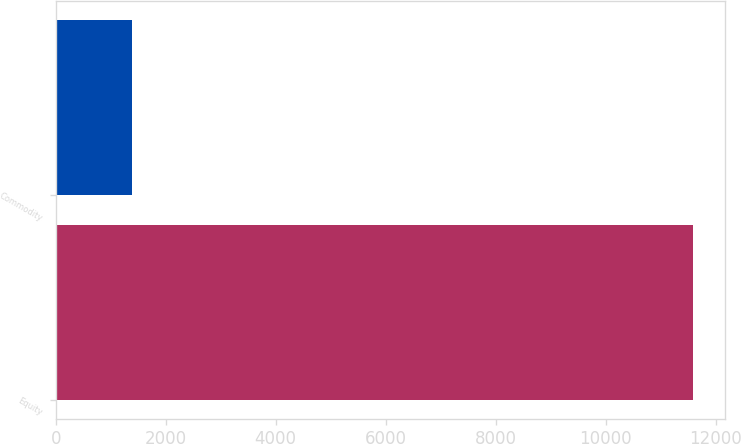<chart> <loc_0><loc_0><loc_500><loc_500><bar_chart><fcel>Equity<fcel>Commodity<nl><fcel>11580<fcel>1379<nl></chart> 